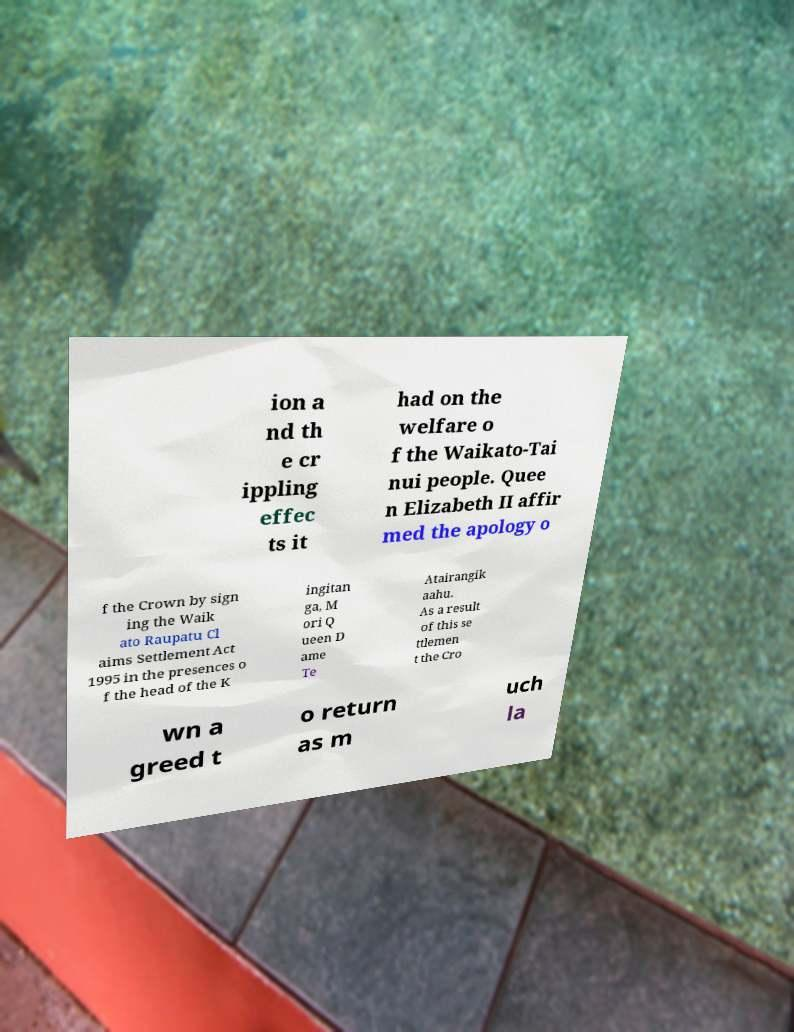Please identify and transcribe the text found in this image. ion a nd th e cr ippling effec ts it had on the welfare o f the Waikato-Tai nui people. Quee n Elizabeth II affir med the apology o f the Crown by sign ing the Waik ato Raupatu Cl aims Settlement Act 1995 in the presences o f the head of the K ingitan ga, M ori Q ueen D ame Te Atairangik aahu. As a result of this se ttlemen t the Cro wn a greed t o return as m uch la 